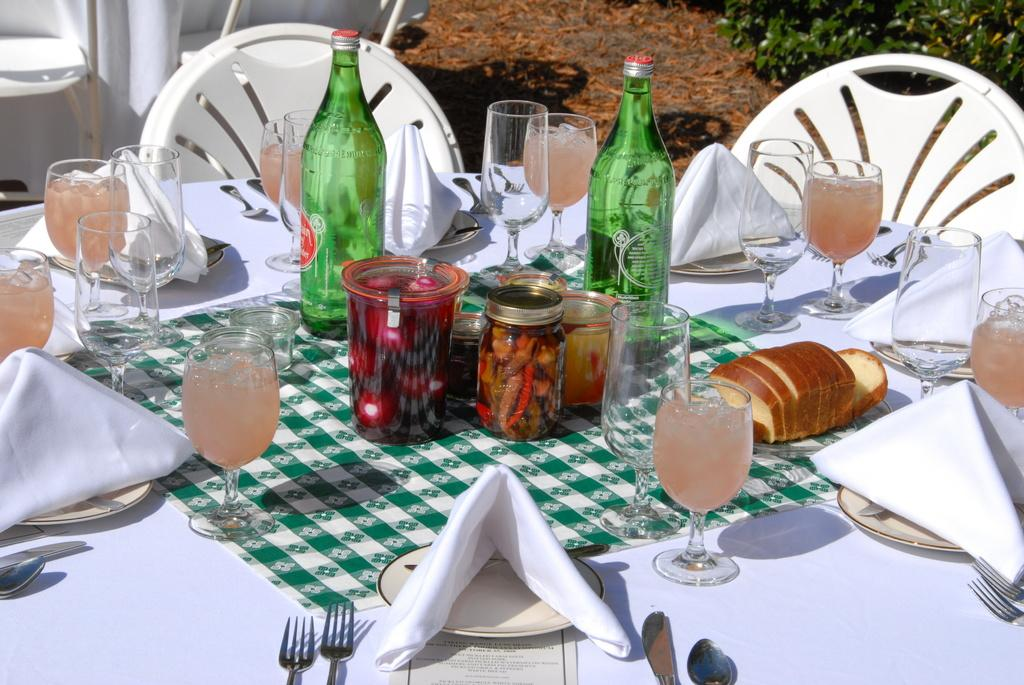What is the color of the table in the image? The table in the image has a white color. What type of containers are on the table? There are glass bottles on the table. What else can be found on the table? There are glasses on the table, along with other objects. How many chairs are beside the table? There are two chairs beside the table. How does the table fold in the image? The table does not fold in the image; it is a stationary table with a white color. 